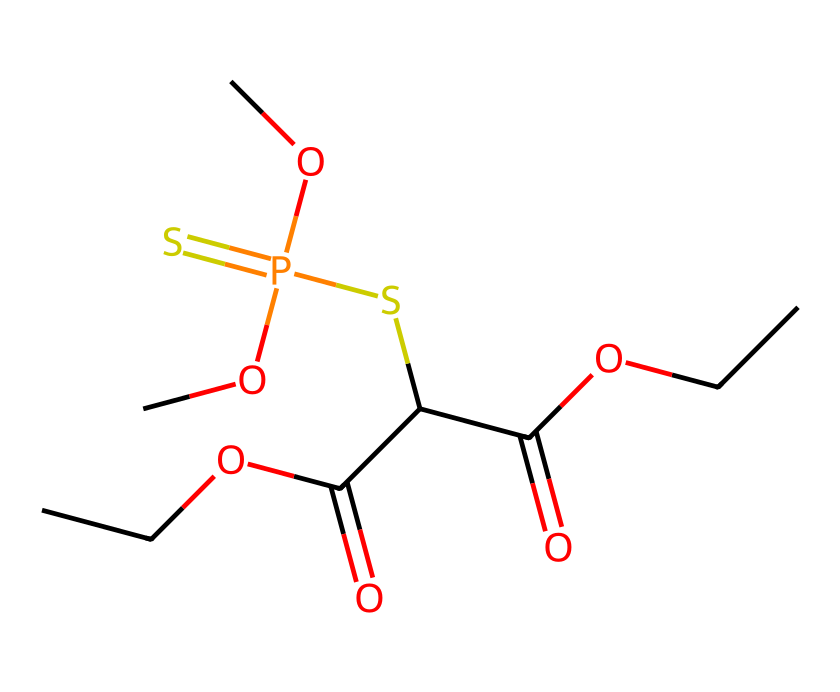How many carbon atoms are present in this compound? By analyzing the SMILES representation, the 'CC' at the beginning indicates 2 carbon atoms, and there are 4 other 'C' symbols appearing in the structure, totaling 6 carbon atoms.
Answer: 6 What is the functional group indicated by "C(=O)" in the SMILES? The "C(=O)" indicates a carbonyl group due to the double bond between carbon and oxygen, which is characteristic of esters or acids in this case.
Answer: carbonyl Which part of the chemical structure is responsible for its activity in pest control? The phosphorus atom (P) and its bonding configuration with sulfur (S) indicate that this compound likely has organophosphate characteristics, related to its insecticidal properties.
Answer: phosphorus What is the total number of oxygen atoms in this compound? Counting directly from the SMILES, there are three "O" atoms in the ester functional groups and one in the carbonyl, totaling 4 oxygen atoms in the structure.
Answer: 4 How does the presence of sulfur affect the properties of this organophosphorus compound compared to typical phosphates? The inclusion of sulfur, as indicated by the "SP(=S)", suggests it's a thiophosphate, which can exhibit different reactivity and toxicity profiles compared to regular phosphates, making it more effective in some pest control applications.
Answer: thiophosphate What is the implication of having multiple ester linkages in terms of volatility and stability? Multiple ester linkages often lead to increased volatility and affect the degradation rate of the compound, which is significant in its application in pest control.
Answer: increased volatility 